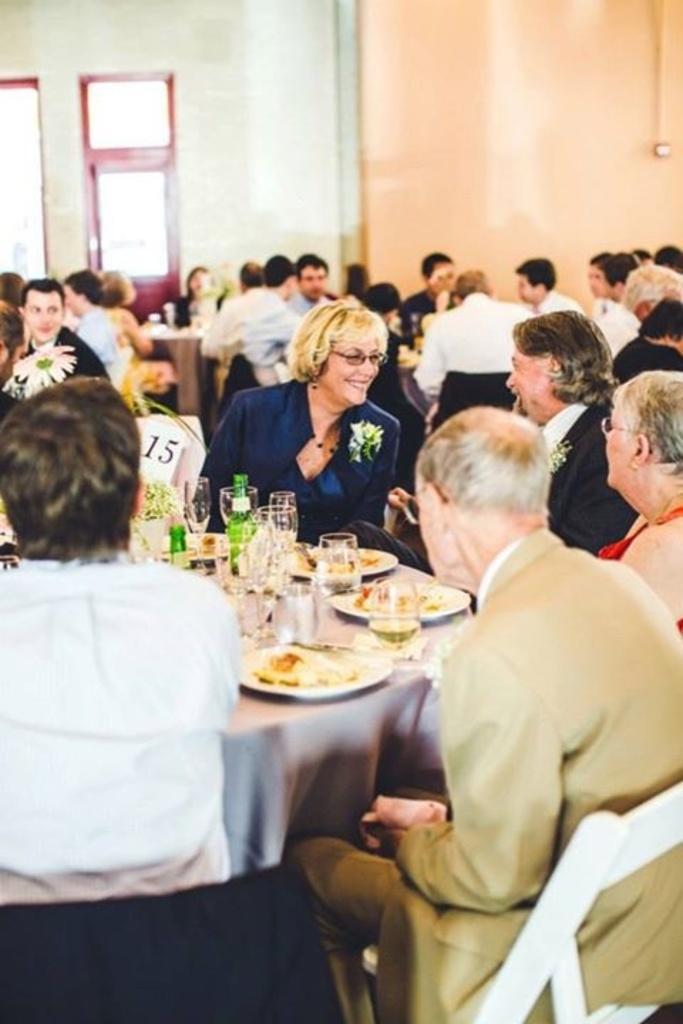How would you summarize this image in a sentence or two? In this picture group of people sitting on the chair. There is a table. On the table we can see plate,food,glass,bottle,flower. On this background we can see wall,window,door. 